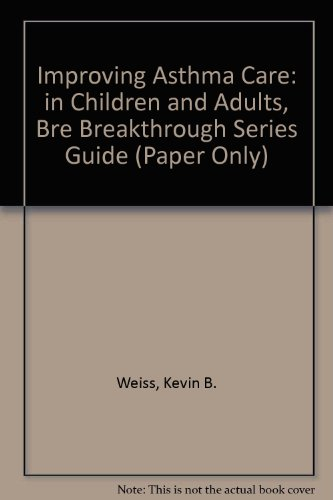Is this book suitable for patients or just healthcare professionals? Primarily designed for healthcare professionals and caregivers, the book provides structured guidelines and knowledge that could also educate patients seeking in-depth understanding of asthma management. 